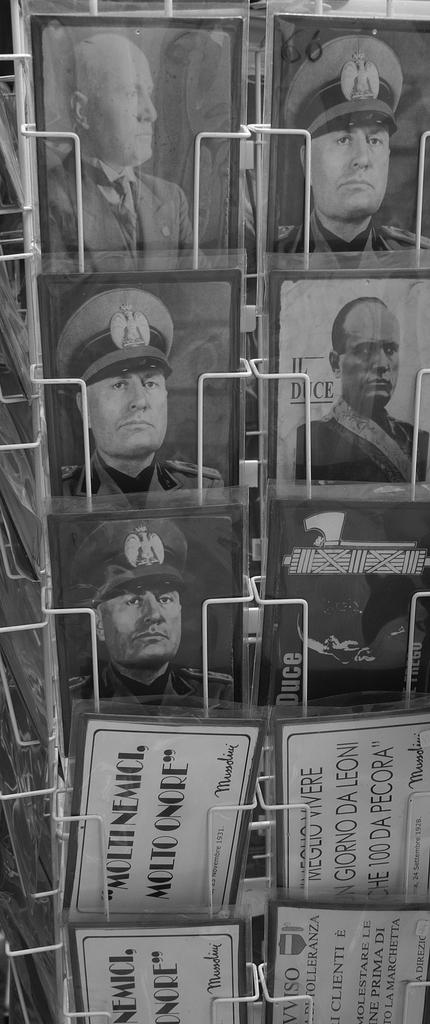<image>
Present a compact description of the photo's key features. Some pictures of military men with the number 66 being visible. 